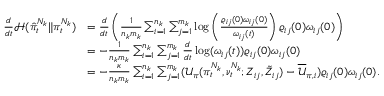<formula> <loc_0><loc_0><loc_500><loc_500>\begin{array} { r l } { \frac { d } { d t } \mathcal { H } ( \hat { \pi } _ { t } ^ { N _ { k } } \| \pi _ { t } ^ { N _ { k } } ) } & { = \frac { d } { d t } \left ( \frac { 1 } { n _ { k } m _ { k } } \sum _ { i = 1 } ^ { n _ { k } } \sum _ { j = 1 } ^ { m _ { k } } \log \left ( \frac { \varrho _ { i j } ( 0 ) \omega _ { i j } ( 0 ) } { \omega _ { i j } ( t ) } \right ) \varrho _ { i j } ( 0 ) \omega _ { i j } ( 0 ) \right ) } \\ & { = - \frac { 1 } { n _ { k } m _ { k } } \sum _ { i = 1 } ^ { n _ { k } } \sum _ { j = 1 } ^ { m _ { k } } \frac { d } { d t } \log ( \omega _ { i j } ( t ) ) { \varrho } _ { i j } ( 0 ) \omega _ { i j } ( 0 ) } \\ & { = - \frac { \kappa } { n _ { k } m _ { k } } \sum _ { i = 1 } ^ { n _ { k } } \sum _ { j = 1 } ^ { m _ { k } } ( \mathcal { U } _ { \pi } ( \pi _ { t } ^ { N _ { k } } , \nu _ { t } ^ { N _ { k } } ; Z _ { i j } , \tilde { Z } _ { i j } ) - \overline { { \mathcal { U } } } _ { \pi , i } ) \varrho _ { i j } ( 0 ) \omega _ { i j } ( 0 ) . } \end{array}</formula> 